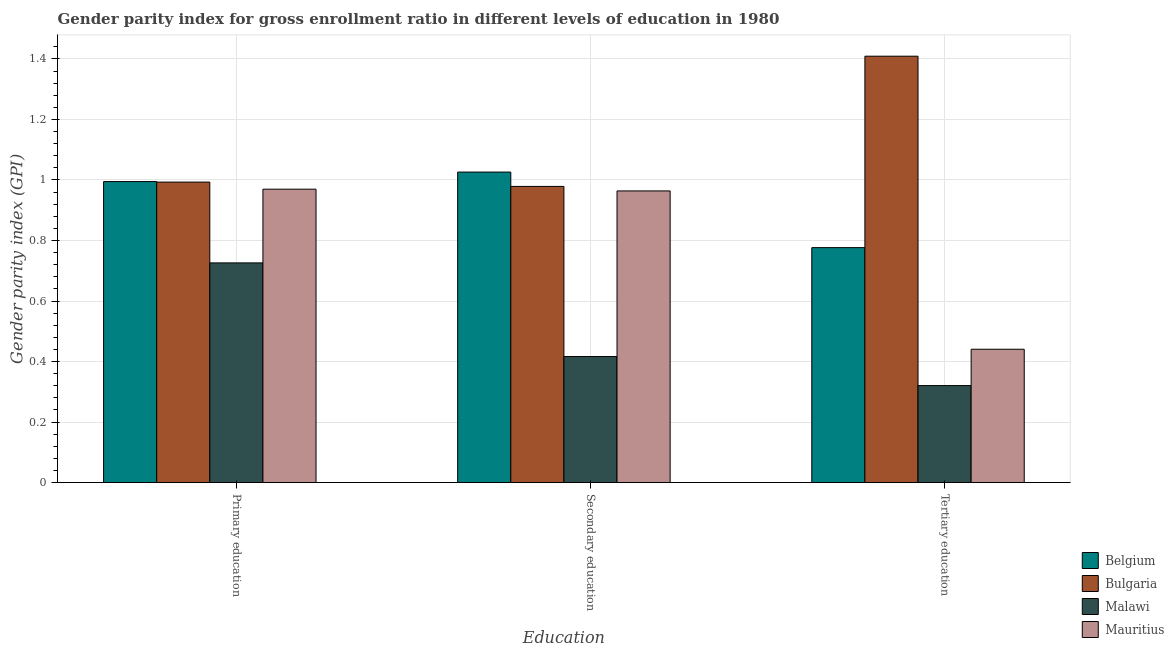Are the number of bars on each tick of the X-axis equal?
Make the answer very short. Yes. What is the label of the 3rd group of bars from the left?
Your answer should be compact. Tertiary education. What is the gender parity index in tertiary education in Mauritius?
Provide a succinct answer. 0.44. Across all countries, what is the maximum gender parity index in secondary education?
Offer a very short reply. 1.03. Across all countries, what is the minimum gender parity index in primary education?
Keep it short and to the point. 0.73. In which country was the gender parity index in secondary education minimum?
Make the answer very short. Malawi. What is the total gender parity index in secondary education in the graph?
Give a very brief answer. 3.39. What is the difference between the gender parity index in secondary education in Malawi and that in Mauritius?
Give a very brief answer. -0.55. What is the difference between the gender parity index in tertiary education in Mauritius and the gender parity index in secondary education in Belgium?
Provide a short and direct response. -0.59. What is the average gender parity index in primary education per country?
Your response must be concise. 0.92. What is the difference between the gender parity index in tertiary education and gender parity index in primary education in Mauritius?
Make the answer very short. -0.53. What is the ratio of the gender parity index in tertiary education in Belgium to that in Malawi?
Provide a succinct answer. 2.42. Is the gender parity index in secondary education in Malawi less than that in Bulgaria?
Provide a succinct answer. Yes. Is the difference between the gender parity index in tertiary education in Belgium and Malawi greater than the difference between the gender parity index in secondary education in Belgium and Malawi?
Provide a short and direct response. No. What is the difference between the highest and the second highest gender parity index in primary education?
Your answer should be compact. 0. What is the difference between the highest and the lowest gender parity index in secondary education?
Your answer should be very brief. 0.61. In how many countries, is the gender parity index in secondary education greater than the average gender parity index in secondary education taken over all countries?
Your answer should be compact. 3. What does the 3rd bar from the left in Primary education represents?
Provide a short and direct response. Malawi. What does the 3rd bar from the right in Tertiary education represents?
Ensure brevity in your answer.  Bulgaria. How many bars are there?
Your answer should be compact. 12. Are all the bars in the graph horizontal?
Your answer should be compact. No. How many countries are there in the graph?
Your response must be concise. 4. What is the difference between two consecutive major ticks on the Y-axis?
Offer a very short reply. 0.2. Are the values on the major ticks of Y-axis written in scientific E-notation?
Make the answer very short. No. Does the graph contain any zero values?
Provide a succinct answer. No. How many legend labels are there?
Your answer should be compact. 4. How are the legend labels stacked?
Offer a terse response. Vertical. What is the title of the graph?
Provide a succinct answer. Gender parity index for gross enrollment ratio in different levels of education in 1980. Does "Haiti" appear as one of the legend labels in the graph?
Offer a terse response. No. What is the label or title of the X-axis?
Ensure brevity in your answer.  Education. What is the label or title of the Y-axis?
Your answer should be compact. Gender parity index (GPI). What is the Gender parity index (GPI) in Belgium in Primary education?
Ensure brevity in your answer.  0.99. What is the Gender parity index (GPI) of Malawi in Primary education?
Your response must be concise. 0.73. What is the Gender parity index (GPI) in Mauritius in Primary education?
Give a very brief answer. 0.97. What is the Gender parity index (GPI) of Belgium in Secondary education?
Your answer should be very brief. 1.03. What is the Gender parity index (GPI) in Bulgaria in Secondary education?
Make the answer very short. 0.98. What is the Gender parity index (GPI) of Malawi in Secondary education?
Offer a very short reply. 0.42. What is the Gender parity index (GPI) of Mauritius in Secondary education?
Make the answer very short. 0.96. What is the Gender parity index (GPI) of Belgium in Tertiary education?
Provide a succinct answer. 0.78. What is the Gender parity index (GPI) in Bulgaria in Tertiary education?
Your response must be concise. 1.41. What is the Gender parity index (GPI) in Malawi in Tertiary education?
Offer a terse response. 0.32. What is the Gender parity index (GPI) in Mauritius in Tertiary education?
Provide a succinct answer. 0.44. Across all Education, what is the maximum Gender parity index (GPI) in Belgium?
Keep it short and to the point. 1.03. Across all Education, what is the maximum Gender parity index (GPI) in Bulgaria?
Provide a short and direct response. 1.41. Across all Education, what is the maximum Gender parity index (GPI) in Malawi?
Provide a short and direct response. 0.73. Across all Education, what is the maximum Gender parity index (GPI) of Mauritius?
Provide a short and direct response. 0.97. Across all Education, what is the minimum Gender parity index (GPI) of Belgium?
Your response must be concise. 0.78. Across all Education, what is the minimum Gender parity index (GPI) in Bulgaria?
Provide a short and direct response. 0.98. Across all Education, what is the minimum Gender parity index (GPI) in Malawi?
Offer a very short reply. 0.32. Across all Education, what is the minimum Gender parity index (GPI) in Mauritius?
Your answer should be compact. 0.44. What is the total Gender parity index (GPI) in Belgium in the graph?
Keep it short and to the point. 2.8. What is the total Gender parity index (GPI) of Bulgaria in the graph?
Give a very brief answer. 3.38. What is the total Gender parity index (GPI) in Malawi in the graph?
Your answer should be very brief. 1.46. What is the total Gender parity index (GPI) of Mauritius in the graph?
Offer a terse response. 2.37. What is the difference between the Gender parity index (GPI) of Belgium in Primary education and that in Secondary education?
Offer a terse response. -0.03. What is the difference between the Gender parity index (GPI) of Bulgaria in Primary education and that in Secondary education?
Your answer should be compact. 0.01. What is the difference between the Gender parity index (GPI) in Malawi in Primary education and that in Secondary education?
Your answer should be compact. 0.31. What is the difference between the Gender parity index (GPI) of Mauritius in Primary education and that in Secondary education?
Make the answer very short. 0.01. What is the difference between the Gender parity index (GPI) in Belgium in Primary education and that in Tertiary education?
Keep it short and to the point. 0.22. What is the difference between the Gender parity index (GPI) in Bulgaria in Primary education and that in Tertiary education?
Your response must be concise. -0.42. What is the difference between the Gender parity index (GPI) of Malawi in Primary education and that in Tertiary education?
Your response must be concise. 0.41. What is the difference between the Gender parity index (GPI) in Mauritius in Primary education and that in Tertiary education?
Offer a very short reply. 0.53. What is the difference between the Gender parity index (GPI) in Belgium in Secondary education and that in Tertiary education?
Give a very brief answer. 0.25. What is the difference between the Gender parity index (GPI) of Bulgaria in Secondary education and that in Tertiary education?
Your response must be concise. -0.43. What is the difference between the Gender parity index (GPI) of Malawi in Secondary education and that in Tertiary education?
Make the answer very short. 0.1. What is the difference between the Gender parity index (GPI) of Mauritius in Secondary education and that in Tertiary education?
Your answer should be very brief. 0.52. What is the difference between the Gender parity index (GPI) in Belgium in Primary education and the Gender parity index (GPI) in Bulgaria in Secondary education?
Provide a short and direct response. 0.02. What is the difference between the Gender parity index (GPI) of Belgium in Primary education and the Gender parity index (GPI) of Malawi in Secondary education?
Ensure brevity in your answer.  0.58. What is the difference between the Gender parity index (GPI) in Belgium in Primary education and the Gender parity index (GPI) in Mauritius in Secondary education?
Your answer should be compact. 0.03. What is the difference between the Gender parity index (GPI) in Bulgaria in Primary education and the Gender parity index (GPI) in Malawi in Secondary education?
Offer a very short reply. 0.58. What is the difference between the Gender parity index (GPI) in Bulgaria in Primary education and the Gender parity index (GPI) in Mauritius in Secondary education?
Offer a terse response. 0.03. What is the difference between the Gender parity index (GPI) of Malawi in Primary education and the Gender parity index (GPI) of Mauritius in Secondary education?
Give a very brief answer. -0.24. What is the difference between the Gender parity index (GPI) of Belgium in Primary education and the Gender parity index (GPI) of Bulgaria in Tertiary education?
Give a very brief answer. -0.41. What is the difference between the Gender parity index (GPI) in Belgium in Primary education and the Gender parity index (GPI) in Malawi in Tertiary education?
Give a very brief answer. 0.67. What is the difference between the Gender parity index (GPI) in Belgium in Primary education and the Gender parity index (GPI) in Mauritius in Tertiary education?
Your answer should be compact. 0.55. What is the difference between the Gender parity index (GPI) in Bulgaria in Primary education and the Gender parity index (GPI) in Malawi in Tertiary education?
Offer a very short reply. 0.67. What is the difference between the Gender parity index (GPI) in Bulgaria in Primary education and the Gender parity index (GPI) in Mauritius in Tertiary education?
Your answer should be very brief. 0.55. What is the difference between the Gender parity index (GPI) of Malawi in Primary education and the Gender parity index (GPI) of Mauritius in Tertiary education?
Give a very brief answer. 0.29. What is the difference between the Gender parity index (GPI) in Belgium in Secondary education and the Gender parity index (GPI) in Bulgaria in Tertiary education?
Give a very brief answer. -0.38. What is the difference between the Gender parity index (GPI) of Belgium in Secondary education and the Gender parity index (GPI) of Malawi in Tertiary education?
Give a very brief answer. 0.71. What is the difference between the Gender parity index (GPI) in Belgium in Secondary education and the Gender parity index (GPI) in Mauritius in Tertiary education?
Make the answer very short. 0.59. What is the difference between the Gender parity index (GPI) of Bulgaria in Secondary education and the Gender parity index (GPI) of Malawi in Tertiary education?
Your answer should be compact. 0.66. What is the difference between the Gender parity index (GPI) in Bulgaria in Secondary education and the Gender parity index (GPI) in Mauritius in Tertiary education?
Your answer should be very brief. 0.54. What is the difference between the Gender parity index (GPI) of Malawi in Secondary education and the Gender parity index (GPI) of Mauritius in Tertiary education?
Give a very brief answer. -0.02. What is the average Gender parity index (GPI) of Belgium per Education?
Keep it short and to the point. 0.93. What is the average Gender parity index (GPI) in Bulgaria per Education?
Your response must be concise. 1.13. What is the average Gender parity index (GPI) of Malawi per Education?
Keep it short and to the point. 0.49. What is the average Gender parity index (GPI) of Mauritius per Education?
Your answer should be compact. 0.79. What is the difference between the Gender parity index (GPI) in Belgium and Gender parity index (GPI) in Bulgaria in Primary education?
Offer a terse response. 0. What is the difference between the Gender parity index (GPI) in Belgium and Gender parity index (GPI) in Malawi in Primary education?
Offer a terse response. 0.27. What is the difference between the Gender parity index (GPI) of Belgium and Gender parity index (GPI) of Mauritius in Primary education?
Offer a terse response. 0.03. What is the difference between the Gender parity index (GPI) of Bulgaria and Gender parity index (GPI) of Malawi in Primary education?
Offer a terse response. 0.27. What is the difference between the Gender parity index (GPI) of Bulgaria and Gender parity index (GPI) of Mauritius in Primary education?
Provide a short and direct response. 0.02. What is the difference between the Gender parity index (GPI) in Malawi and Gender parity index (GPI) in Mauritius in Primary education?
Offer a very short reply. -0.24. What is the difference between the Gender parity index (GPI) of Belgium and Gender parity index (GPI) of Bulgaria in Secondary education?
Ensure brevity in your answer.  0.05. What is the difference between the Gender parity index (GPI) of Belgium and Gender parity index (GPI) of Malawi in Secondary education?
Offer a very short reply. 0.61. What is the difference between the Gender parity index (GPI) of Belgium and Gender parity index (GPI) of Mauritius in Secondary education?
Offer a terse response. 0.06. What is the difference between the Gender parity index (GPI) of Bulgaria and Gender parity index (GPI) of Malawi in Secondary education?
Provide a succinct answer. 0.56. What is the difference between the Gender parity index (GPI) in Bulgaria and Gender parity index (GPI) in Mauritius in Secondary education?
Your answer should be very brief. 0.01. What is the difference between the Gender parity index (GPI) in Malawi and Gender parity index (GPI) in Mauritius in Secondary education?
Give a very brief answer. -0.55. What is the difference between the Gender parity index (GPI) of Belgium and Gender parity index (GPI) of Bulgaria in Tertiary education?
Give a very brief answer. -0.63. What is the difference between the Gender parity index (GPI) in Belgium and Gender parity index (GPI) in Malawi in Tertiary education?
Provide a short and direct response. 0.46. What is the difference between the Gender parity index (GPI) of Belgium and Gender parity index (GPI) of Mauritius in Tertiary education?
Give a very brief answer. 0.34. What is the difference between the Gender parity index (GPI) in Bulgaria and Gender parity index (GPI) in Malawi in Tertiary education?
Offer a terse response. 1.09. What is the difference between the Gender parity index (GPI) of Bulgaria and Gender parity index (GPI) of Mauritius in Tertiary education?
Offer a terse response. 0.97. What is the difference between the Gender parity index (GPI) in Malawi and Gender parity index (GPI) in Mauritius in Tertiary education?
Your response must be concise. -0.12. What is the ratio of the Gender parity index (GPI) in Belgium in Primary education to that in Secondary education?
Offer a terse response. 0.97. What is the ratio of the Gender parity index (GPI) in Bulgaria in Primary education to that in Secondary education?
Make the answer very short. 1.01. What is the ratio of the Gender parity index (GPI) of Malawi in Primary education to that in Secondary education?
Your response must be concise. 1.74. What is the ratio of the Gender parity index (GPI) of Mauritius in Primary education to that in Secondary education?
Your answer should be very brief. 1.01. What is the ratio of the Gender parity index (GPI) of Belgium in Primary education to that in Tertiary education?
Give a very brief answer. 1.28. What is the ratio of the Gender parity index (GPI) in Bulgaria in Primary education to that in Tertiary education?
Give a very brief answer. 0.7. What is the ratio of the Gender parity index (GPI) in Malawi in Primary education to that in Tertiary education?
Offer a terse response. 2.26. What is the ratio of the Gender parity index (GPI) of Mauritius in Primary education to that in Tertiary education?
Offer a very short reply. 2.2. What is the ratio of the Gender parity index (GPI) of Belgium in Secondary education to that in Tertiary education?
Give a very brief answer. 1.32. What is the ratio of the Gender parity index (GPI) in Bulgaria in Secondary education to that in Tertiary education?
Ensure brevity in your answer.  0.69. What is the ratio of the Gender parity index (GPI) in Malawi in Secondary education to that in Tertiary education?
Offer a very short reply. 1.3. What is the ratio of the Gender parity index (GPI) of Mauritius in Secondary education to that in Tertiary education?
Your answer should be very brief. 2.19. What is the difference between the highest and the second highest Gender parity index (GPI) in Belgium?
Make the answer very short. 0.03. What is the difference between the highest and the second highest Gender parity index (GPI) of Bulgaria?
Make the answer very short. 0.42. What is the difference between the highest and the second highest Gender parity index (GPI) in Malawi?
Your answer should be compact. 0.31. What is the difference between the highest and the second highest Gender parity index (GPI) in Mauritius?
Provide a short and direct response. 0.01. What is the difference between the highest and the lowest Gender parity index (GPI) in Belgium?
Offer a very short reply. 0.25. What is the difference between the highest and the lowest Gender parity index (GPI) of Bulgaria?
Give a very brief answer. 0.43. What is the difference between the highest and the lowest Gender parity index (GPI) in Malawi?
Offer a very short reply. 0.41. What is the difference between the highest and the lowest Gender parity index (GPI) in Mauritius?
Provide a short and direct response. 0.53. 